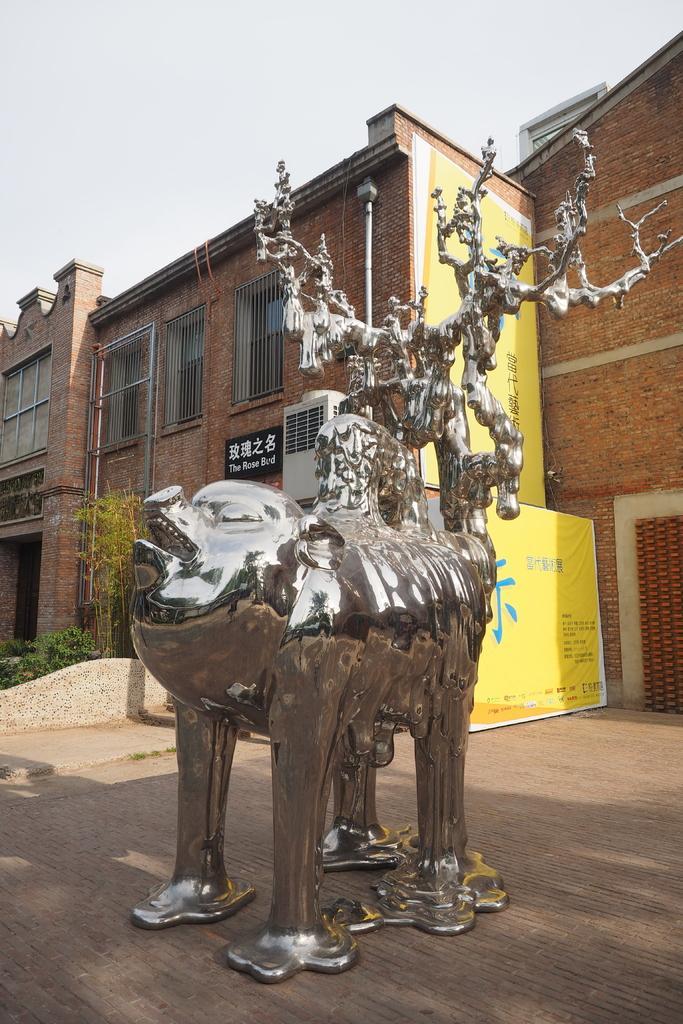Can you describe this image briefly? This picture is of outside. In the center there is a sculpture and a yellow color banner with a text printed on it. On the right corner there is a door. In the background we can see the buildings, pole, windows, board, air cooler and some plants and the sky. 